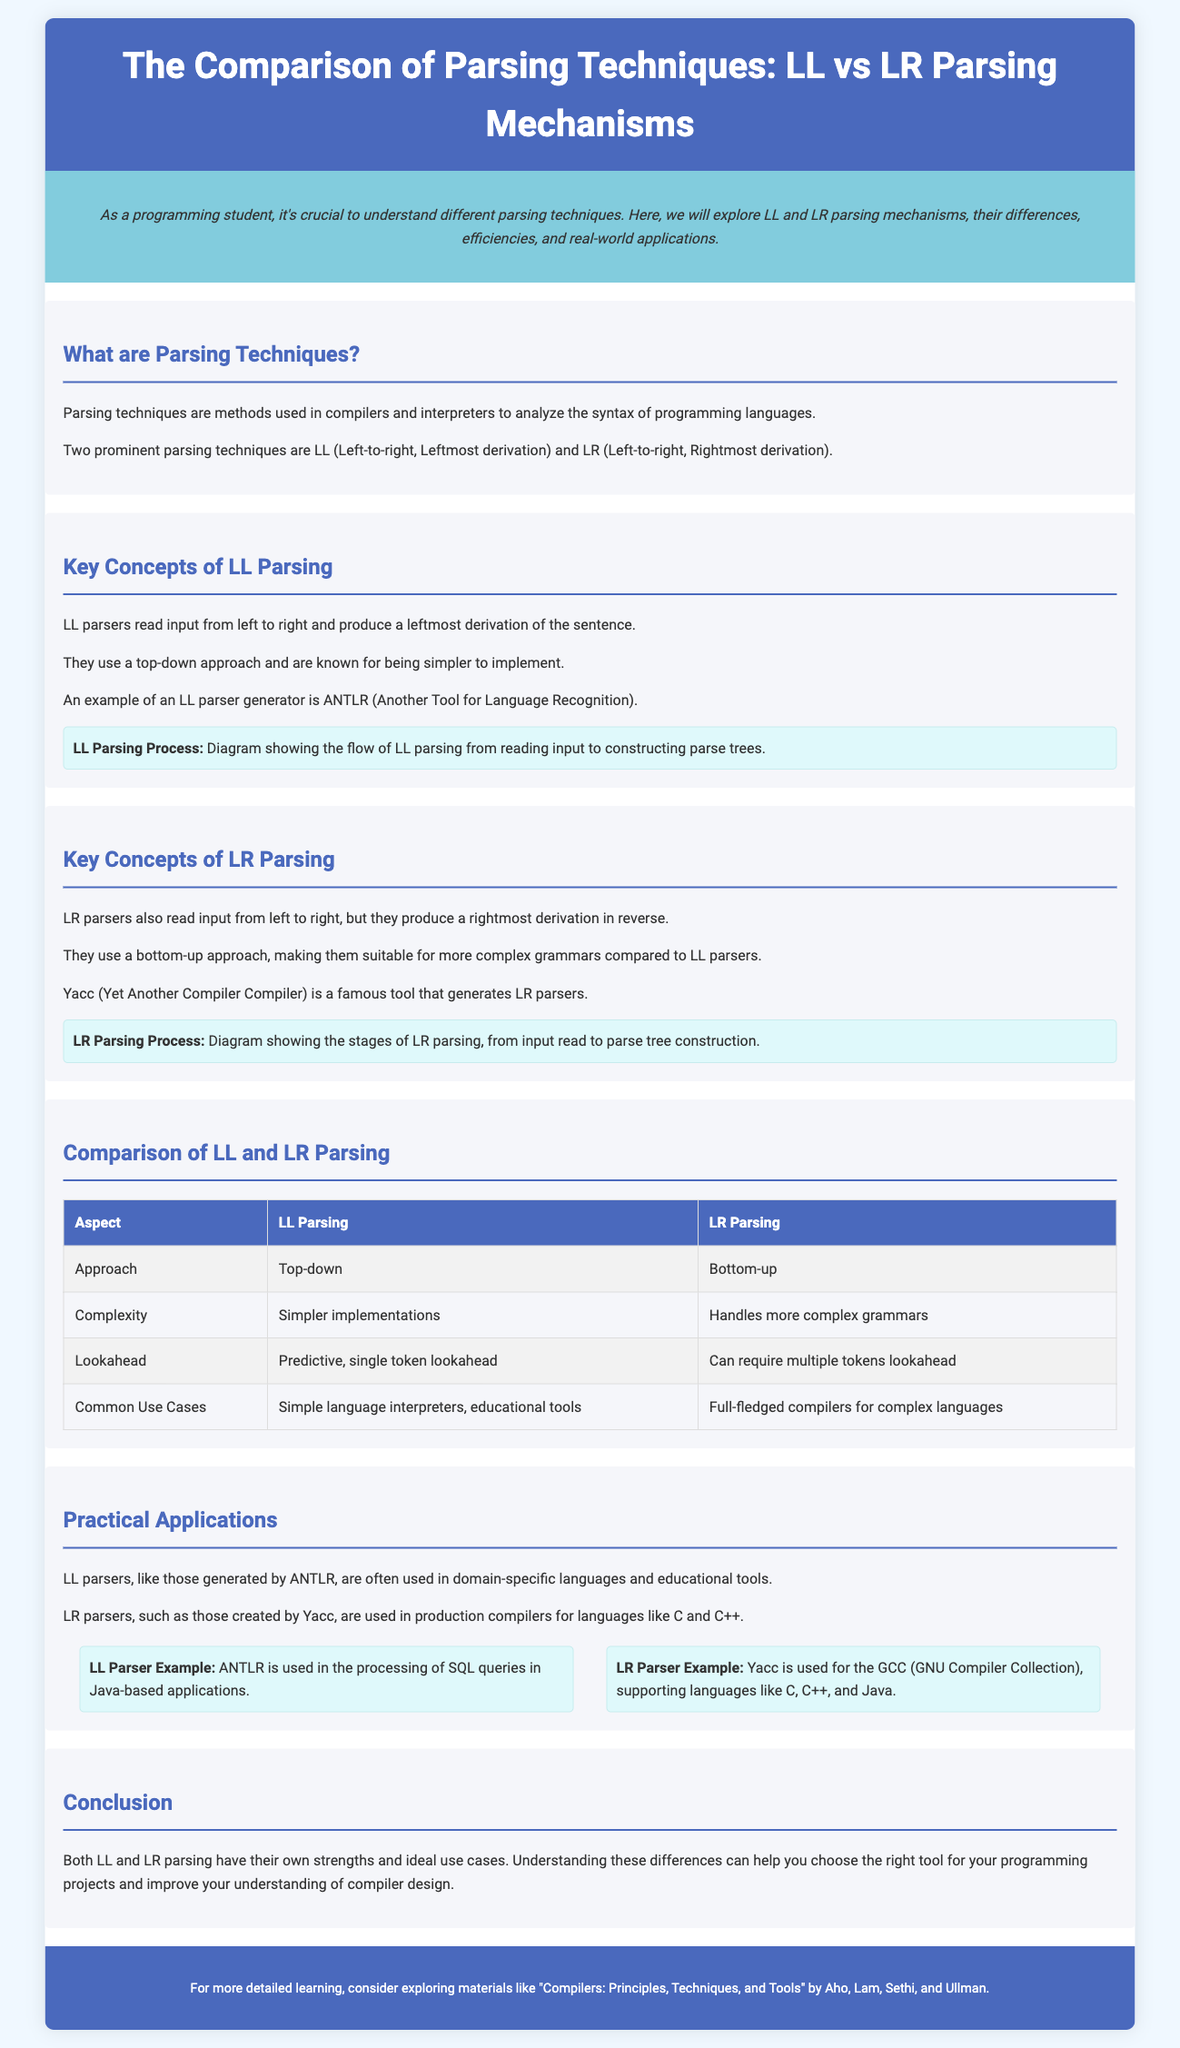What are the two prominent parsing techniques mentioned? The document states that the two prominent parsing techniques are LL and LR.
Answer: LL and LR What approach does LL parsing use? The document specifies that LL parsing uses a top-down approach.
Answer: Top-down What is a key tool for generating LL parsers? According to the document, ANTLR is an example of an LL parser generator.
Answer: ANTLR Which parser is suitable for complex grammars? The document indicates that LR parsing handles more complex grammars compared to LL parsing.
Answer: LR parsing What does LR stand for in the context of parsing? The acronym "LR" in this context refers to Left-to-right, Rightmost derivation.
Answer: Left-to-right, Rightmost derivation What is a common use case for LL parsers? The document mentions that LL parsers are often used in simple language interpreters and educational tools.
Answer: Simple language interpreters, educational tools What parsing technique does Yacc generate? The document specifies that Yacc is used to generate LR parsers.
Answer: LR parsers How does the lookahead strategy differ between LL and LR parsing? The document notes that LL parsing uses predictive, single token lookahead, while LR parsing can require multiple tokens lookahead.
Answer: Predictive, single token lookahead; multiple tokens lookahead Which book is recommended for detailed learning on compilers? The document recommends "Compilers: Principles, Techniques, and Tools" by Aho, Lam, Sethi, and Ullman.
Answer: Compilers: Principles, Techniques, and Tools 